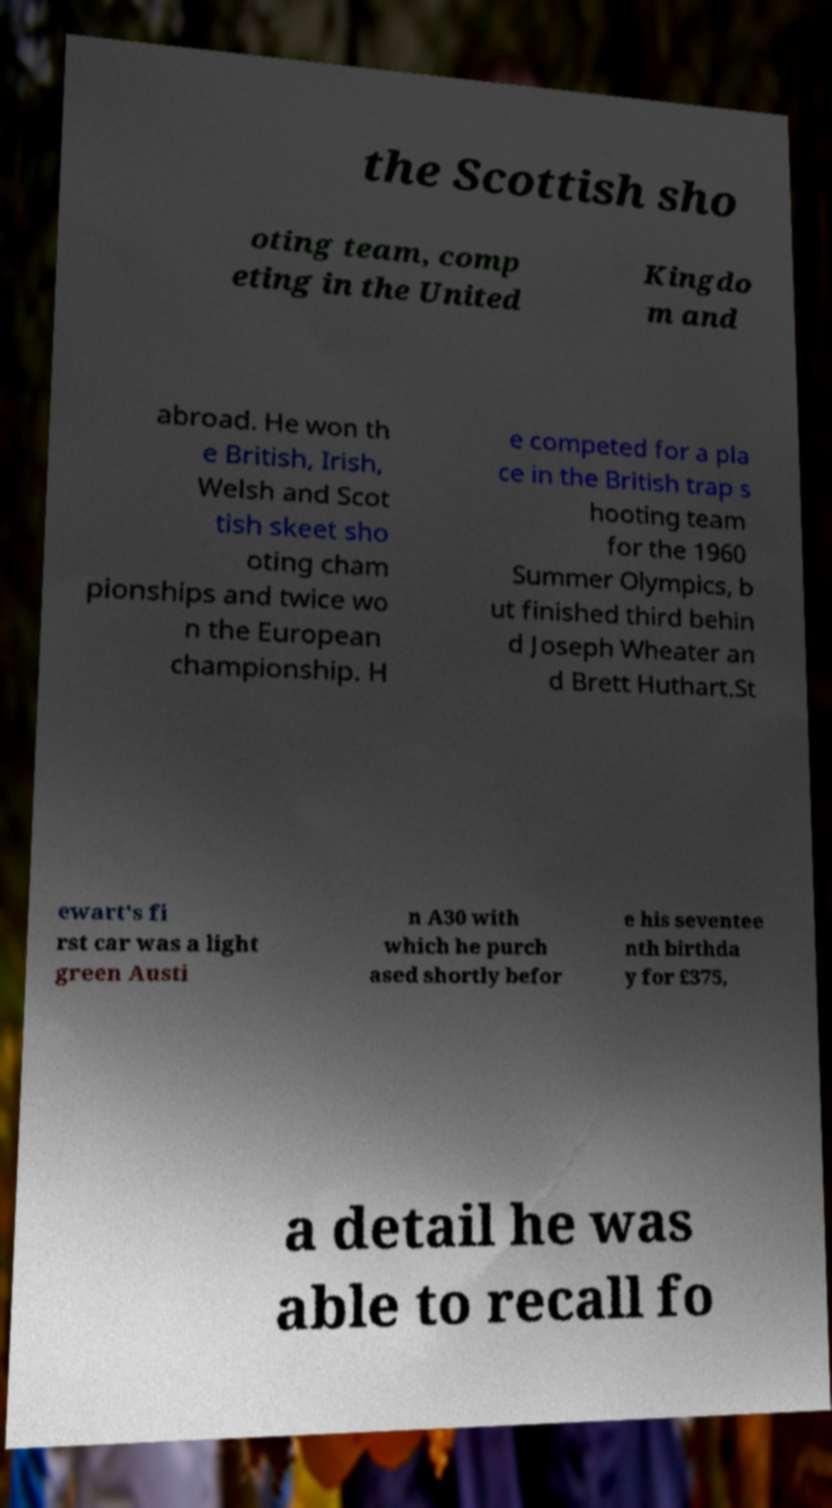Please identify and transcribe the text found in this image. the Scottish sho oting team, comp eting in the United Kingdo m and abroad. He won th e British, Irish, Welsh and Scot tish skeet sho oting cham pionships and twice wo n the European championship. H e competed for a pla ce in the British trap s hooting team for the 1960 Summer Olympics, b ut finished third behin d Joseph Wheater an d Brett Huthart.St ewart's fi rst car was a light green Austi n A30 with which he purch ased shortly befor e his seventee nth birthda y for £375, a detail he was able to recall fo 